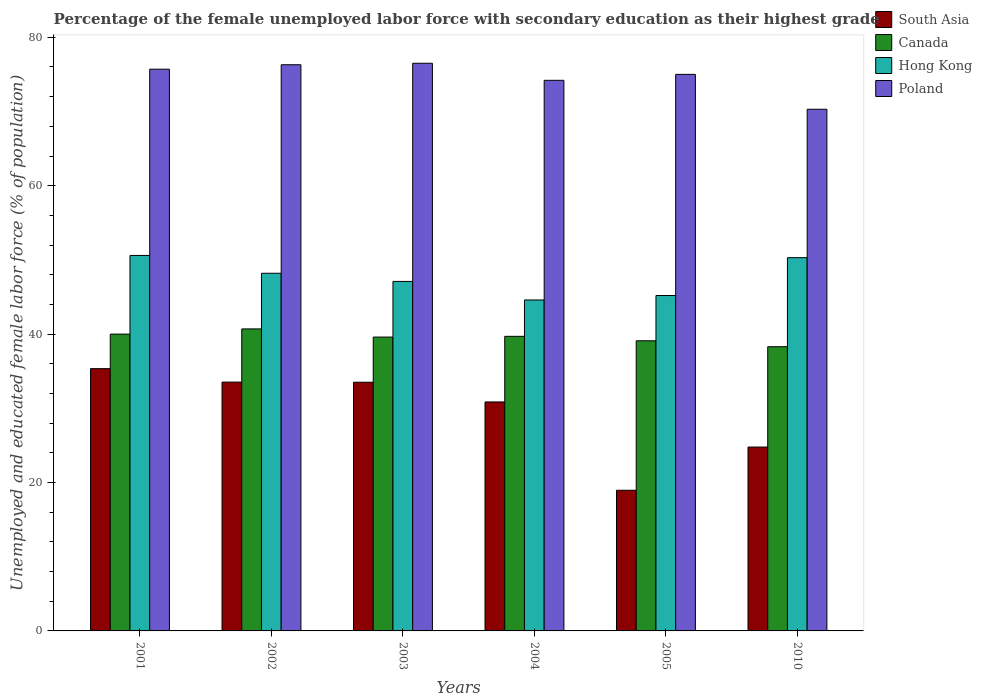How many different coloured bars are there?
Give a very brief answer. 4. Are the number of bars per tick equal to the number of legend labels?
Offer a very short reply. Yes. How many bars are there on the 4th tick from the left?
Offer a very short reply. 4. How many bars are there on the 5th tick from the right?
Ensure brevity in your answer.  4. What is the label of the 3rd group of bars from the left?
Give a very brief answer. 2003. In how many cases, is the number of bars for a given year not equal to the number of legend labels?
Ensure brevity in your answer.  0. What is the percentage of the unemployed female labor force with secondary education in South Asia in 2003?
Provide a short and direct response. 33.51. Across all years, what is the maximum percentage of the unemployed female labor force with secondary education in Canada?
Provide a succinct answer. 40.7. Across all years, what is the minimum percentage of the unemployed female labor force with secondary education in Canada?
Provide a short and direct response. 38.3. In which year was the percentage of the unemployed female labor force with secondary education in Poland maximum?
Your answer should be compact. 2003. In which year was the percentage of the unemployed female labor force with secondary education in Poland minimum?
Ensure brevity in your answer.  2010. What is the total percentage of the unemployed female labor force with secondary education in Canada in the graph?
Provide a succinct answer. 237.4. What is the difference between the percentage of the unemployed female labor force with secondary education in Hong Kong in 2001 and that in 2010?
Offer a very short reply. 0.3. What is the difference between the percentage of the unemployed female labor force with secondary education in Canada in 2001 and the percentage of the unemployed female labor force with secondary education in Hong Kong in 2004?
Keep it short and to the point. -4.6. What is the average percentage of the unemployed female labor force with secondary education in South Asia per year?
Keep it short and to the point. 29.5. In how many years, is the percentage of the unemployed female labor force with secondary education in Canada greater than 72 %?
Offer a very short reply. 0. What is the ratio of the percentage of the unemployed female labor force with secondary education in South Asia in 2004 to that in 2010?
Ensure brevity in your answer.  1.25. Is the percentage of the unemployed female labor force with secondary education in Canada in 2003 less than that in 2010?
Provide a short and direct response. No. Is the difference between the percentage of the unemployed female labor force with secondary education in Hong Kong in 2002 and 2005 greater than the difference between the percentage of the unemployed female labor force with secondary education in Canada in 2002 and 2005?
Keep it short and to the point. Yes. What is the difference between the highest and the second highest percentage of the unemployed female labor force with secondary education in Hong Kong?
Provide a succinct answer. 0.3. What is the difference between the highest and the lowest percentage of the unemployed female labor force with secondary education in Canada?
Offer a terse response. 2.4. Is the sum of the percentage of the unemployed female labor force with secondary education in Hong Kong in 2003 and 2010 greater than the maximum percentage of the unemployed female labor force with secondary education in Poland across all years?
Keep it short and to the point. Yes. What does the 3rd bar from the left in 2002 represents?
Make the answer very short. Hong Kong. Are all the bars in the graph horizontal?
Provide a short and direct response. No. How many years are there in the graph?
Offer a very short reply. 6. What is the difference between two consecutive major ticks on the Y-axis?
Your response must be concise. 20. Are the values on the major ticks of Y-axis written in scientific E-notation?
Your answer should be compact. No. Does the graph contain any zero values?
Ensure brevity in your answer.  No. Does the graph contain grids?
Keep it short and to the point. No. How are the legend labels stacked?
Ensure brevity in your answer.  Vertical. What is the title of the graph?
Provide a succinct answer. Percentage of the female unemployed labor force with secondary education as their highest grade. What is the label or title of the X-axis?
Give a very brief answer. Years. What is the label or title of the Y-axis?
Offer a very short reply. Unemployed and educated female labor force (% of population). What is the Unemployed and educated female labor force (% of population) of South Asia in 2001?
Give a very brief answer. 35.34. What is the Unemployed and educated female labor force (% of population) in Canada in 2001?
Ensure brevity in your answer.  40. What is the Unemployed and educated female labor force (% of population) of Hong Kong in 2001?
Your answer should be very brief. 50.6. What is the Unemployed and educated female labor force (% of population) of Poland in 2001?
Your answer should be very brief. 75.7. What is the Unemployed and educated female labor force (% of population) in South Asia in 2002?
Offer a very short reply. 33.53. What is the Unemployed and educated female labor force (% of population) of Canada in 2002?
Your response must be concise. 40.7. What is the Unemployed and educated female labor force (% of population) in Hong Kong in 2002?
Your answer should be compact. 48.2. What is the Unemployed and educated female labor force (% of population) of Poland in 2002?
Keep it short and to the point. 76.3. What is the Unemployed and educated female labor force (% of population) of South Asia in 2003?
Offer a very short reply. 33.51. What is the Unemployed and educated female labor force (% of population) in Canada in 2003?
Offer a very short reply. 39.6. What is the Unemployed and educated female labor force (% of population) in Hong Kong in 2003?
Offer a very short reply. 47.1. What is the Unemployed and educated female labor force (% of population) in Poland in 2003?
Give a very brief answer. 76.5. What is the Unemployed and educated female labor force (% of population) of South Asia in 2004?
Give a very brief answer. 30.86. What is the Unemployed and educated female labor force (% of population) of Canada in 2004?
Ensure brevity in your answer.  39.7. What is the Unemployed and educated female labor force (% of population) in Hong Kong in 2004?
Offer a very short reply. 44.6. What is the Unemployed and educated female labor force (% of population) in Poland in 2004?
Give a very brief answer. 74.2. What is the Unemployed and educated female labor force (% of population) of South Asia in 2005?
Provide a succinct answer. 18.96. What is the Unemployed and educated female labor force (% of population) in Canada in 2005?
Make the answer very short. 39.1. What is the Unemployed and educated female labor force (% of population) of Hong Kong in 2005?
Your answer should be very brief. 45.2. What is the Unemployed and educated female labor force (% of population) in South Asia in 2010?
Offer a very short reply. 24.78. What is the Unemployed and educated female labor force (% of population) of Canada in 2010?
Provide a succinct answer. 38.3. What is the Unemployed and educated female labor force (% of population) in Hong Kong in 2010?
Offer a terse response. 50.3. What is the Unemployed and educated female labor force (% of population) in Poland in 2010?
Offer a very short reply. 70.3. Across all years, what is the maximum Unemployed and educated female labor force (% of population) of South Asia?
Provide a succinct answer. 35.34. Across all years, what is the maximum Unemployed and educated female labor force (% of population) in Canada?
Your answer should be very brief. 40.7. Across all years, what is the maximum Unemployed and educated female labor force (% of population) of Hong Kong?
Make the answer very short. 50.6. Across all years, what is the maximum Unemployed and educated female labor force (% of population) in Poland?
Give a very brief answer. 76.5. Across all years, what is the minimum Unemployed and educated female labor force (% of population) of South Asia?
Give a very brief answer. 18.96. Across all years, what is the minimum Unemployed and educated female labor force (% of population) of Canada?
Provide a short and direct response. 38.3. Across all years, what is the minimum Unemployed and educated female labor force (% of population) of Hong Kong?
Make the answer very short. 44.6. Across all years, what is the minimum Unemployed and educated female labor force (% of population) of Poland?
Offer a terse response. 70.3. What is the total Unemployed and educated female labor force (% of population) of South Asia in the graph?
Offer a terse response. 176.98. What is the total Unemployed and educated female labor force (% of population) of Canada in the graph?
Offer a terse response. 237.4. What is the total Unemployed and educated female labor force (% of population) in Hong Kong in the graph?
Keep it short and to the point. 286. What is the total Unemployed and educated female labor force (% of population) of Poland in the graph?
Ensure brevity in your answer.  448. What is the difference between the Unemployed and educated female labor force (% of population) in South Asia in 2001 and that in 2002?
Your answer should be very brief. 1.81. What is the difference between the Unemployed and educated female labor force (% of population) in Canada in 2001 and that in 2002?
Offer a terse response. -0.7. What is the difference between the Unemployed and educated female labor force (% of population) of Poland in 2001 and that in 2002?
Keep it short and to the point. -0.6. What is the difference between the Unemployed and educated female labor force (% of population) of South Asia in 2001 and that in 2003?
Your answer should be very brief. 1.83. What is the difference between the Unemployed and educated female labor force (% of population) of Canada in 2001 and that in 2003?
Offer a terse response. 0.4. What is the difference between the Unemployed and educated female labor force (% of population) in Hong Kong in 2001 and that in 2003?
Make the answer very short. 3.5. What is the difference between the Unemployed and educated female labor force (% of population) in Poland in 2001 and that in 2003?
Keep it short and to the point. -0.8. What is the difference between the Unemployed and educated female labor force (% of population) of South Asia in 2001 and that in 2004?
Provide a succinct answer. 4.49. What is the difference between the Unemployed and educated female labor force (% of population) in Hong Kong in 2001 and that in 2004?
Your answer should be very brief. 6. What is the difference between the Unemployed and educated female labor force (% of population) of South Asia in 2001 and that in 2005?
Keep it short and to the point. 16.39. What is the difference between the Unemployed and educated female labor force (% of population) in Canada in 2001 and that in 2005?
Provide a succinct answer. 0.9. What is the difference between the Unemployed and educated female labor force (% of population) of South Asia in 2001 and that in 2010?
Make the answer very short. 10.57. What is the difference between the Unemployed and educated female labor force (% of population) of Canada in 2001 and that in 2010?
Offer a very short reply. 1.7. What is the difference between the Unemployed and educated female labor force (% of population) in Hong Kong in 2001 and that in 2010?
Keep it short and to the point. 0.3. What is the difference between the Unemployed and educated female labor force (% of population) of Poland in 2001 and that in 2010?
Make the answer very short. 5.4. What is the difference between the Unemployed and educated female labor force (% of population) of South Asia in 2002 and that in 2003?
Ensure brevity in your answer.  0.02. What is the difference between the Unemployed and educated female labor force (% of population) of Canada in 2002 and that in 2003?
Give a very brief answer. 1.1. What is the difference between the Unemployed and educated female labor force (% of population) in South Asia in 2002 and that in 2004?
Offer a very short reply. 2.67. What is the difference between the Unemployed and educated female labor force (% of population) in Hong Kong in 2002 and that in 2004?
Make the answer very short. 3.6. What is the difference between the Unemployed and educated female labor force (% of population) in Poland in 2002 and that in 2004?
Provide a short and direct response. 2.1. What is the difference between the Unemployed and educated female labor force (% of population) of South Asia in 2002 and that in 2005?
Keep it short and to the point. 14.58. What is the difference between the Unemployed and educated female labor force (% of population) in Canada in 2002 and that in 2005?
Your answer should be very brief. 1.6. What is the difference between the Unemployed and educated female labor force (% of population) in South Asia in 2002 and that in 2010?
Your response must be concise. 8.75. What is the difference between the Unemployed and educated female labor force (% of population) in Canada in 2002 and that in 2010?
Keep it short and to the point. 2.4. What is the difference between the Unemployed and educated female labor force (% of population) in Hong Kong in 2002 and that in 2010?
Offer a very short reply. -2.1. What is the difference between the Unemployed and educated female labor force (% of population) of Poland in 2002 and that in 2010?
Give a very brief answer. 6. What is the difference between the Unemployed and educated female labor force (% of population) in South Asia in 2003 and that in 2004?
Your response must be concise. 2.66. What is the difference between the Unemployed and educated female labor force (% of population) in South Asia in 2003 and that in 2005?
Offer a terse response. 14.56. What is the difference between the Unemployed and educated female labor force (% of population) in Canada in 2003 and that in 2005?
Ensure brevity in your answer.  0.5. What is the difference between the Unemployed and educated female labor force (% of population) of Poland in 2003 and that in 2005?
Offer a terse response. 1.5. What is the difference between the Unemployed and educated female labor force (% of population) of South Asia in 2003 and that in 2010?
Provide a short and direct response. 8.74. What is the difference between the Unemployed and educated female labor force (% of population) of Poland in 2003 and that in 2010?
Offer a terse response. 6.2. What is the difference between the Unemployed and educated female labor force (% of population) in South Asia in 2004 and that in 2005?
Give a very brief answer. 11.9. What is the difference between the Unemployed and educated female labor force (% of population) in Canada in 2004 and that in 2005?
Your response must be concise. 0.6. What is the difference between the Unemployed and educated female labor force (% of population) of Poland in 2004 and that in 2005?
Your answer should be very brief. -0.8. What is the difference between the Unemployed and educated female labor force (% of population) in South Asia in 2004 and that in 2010?
Provide a succinct answer. 6.08. What is the difference between the Unemployed and educated female labor force (% of population) of Canada in 2004 and that in 2010?
Your answer should be compact. 1.4. What is the difference between the Unemployed and educated female labor force (% of population) in South Asia in 2005 and that in 2010?
Provide a short and direct response. -5.82. What is the difference between the Unemployed and educated female labor force (% of population) in Poland in 2005 and that in 2010?
Your answer should be compact. 4.7. What is the difference between the Unemployed and educated female labor force (% of population) in South Asia in 2001 and the Unemployed and educated female labor force (% of population) in Canada in 2002?
Offer a very short reply. -5.36. What is the difference between the Unemployed and educated female labor force (% of population) in South Asia in 2001 and the Unemployed and educated female labor force (% of population) in Hong Kong in 2002?
Ensure brevity in your answer.  -12.86. What is the difference between the Unemployed and educated female labor force (% of population) of South Asia in 2001 and the Unemployed and educated female labor force (% of population) of Poland in 2002?
Your response must be concise. -40.96. What is the difference between the Unemployed and educated female labor force (% of population) in Canada in 2001 and the Unemployed and educated female labor force (% of population) in Poland in 2002?
Make the answer very short. -36.3. What is the difference between the Unemployed and educated female labor force (% of population) of Hong Kong in 2001 and the Unemployed and educated female labor force (% of population) of Poland in 2002?
Your response must be concise. -25.7. What is the difference between the Unemployed and educated female labor force (% of population) of South Asia in 2001 and the Unemployed and educated female labor force (% of population) of Canada in 2003?
Your response must be concise. -4.26. What is the difference between the Unemployed and educated female labor force (% of population) in South Asia in 2001 and the Unemployed and educated female labor force (% of population) in Hong Kong in 2003?
Provide a short and direct response. -11.76. What is the difference between the Unemployed and educated female labor force (% of population) of South Asia in 2001 and the Unemployed and educated female labor force (% of population) of Poland in 2003?
Provide a succinct answer. -41.16. What is the difference between the Unemployed and educated female labor force (% of population) of Canada in 2001 and the Unemployed and educated female labor force (% of population) of Poland in 2003?
Your response must be concise. -36.5. What is the difference between the Unemployed and educated female labor force (% of population) of Hong Kong in 2001 and the Unemployed and educated female labor force (% of population) of Poland in 2003?
Ensure brevity in your answer.  -25.9. What is the difference between the Unemployed and educated female labor force (% of population) of South Asia in 2001 and the Unemployed and educated female labor force (% of population) of Canada in 2004?
Offer a terse response. -4.36. What is the difference between the Unemployed and educated female labor force (% of population) of South Asia in 2001 and the Unemployed and educated female labor force (% of population) of Hong Kong in 2004?
Provide a short and direct response. -9.26. What is the difference between the Unemployed and educated female labor force (% of population) of South Asia in 2001 and the Unemployed and educated female labor force (% of population) of Poland in 2004?
Provide a succinct answer. -38.86. What is the difference between the Unemployed and educated female labor force (% of population) of Canada in 2001 and the Unemployed and educated female labor force (% of population) of Hong Kong in 2004?
Provide a short and direct response. -4.6. What is the difference between the Unemployed and educated female labor force (% of population) of Canada in 2001 and the Unemployed and educated female labor force (% of population) of Poland in 2004?
Your answer should be compact. -34.2. What is the difference between the Unemployed and educated female labor force (% of population) in Hong Kong in 2001 and the Unemployed and educated female labor force (% of population) in Poland in 2004?
Offer a very short reply. -23.6. What is the difference between the Unemployed and educated female labor force (% of population) of South Asia in 2001 and the Unemployed and educated female labor force (% of population) of Canada in 2005?
Offer a terse response. -3.76. What is the difference between the Unemployed and educated female labor force (% of population) of South Asia in 2001 and the Unemployed and educated female labor force (% of population) of Hong Kong in 2005?
Offer a terse response. -9.86. What is the difference between the Unemployed and educated female labor force (% of population) in South Asia in 2001 and the Unemployed and educated female labor force (% of population) in Poland in 2005?
Your response must be concise. -39.66. What is the difference between the Unemployed and educated female labor force (% of population) of Canada in 2001 and the Unemployed and educated female labor force (% of population) of Poland in 2005?
Keep it short and to the point. -35. What is the difference between the Unemployed and educated female labor force (% of population) in Hong Kong in 2001 and the Unemployed and educated female labor force (% of population) in Poland in 2005?
Provide a succinct answer. -24.4. What is the difference between the Unemployed and educated female labor force (% of population) of South Asia in 2001 and the Unemployed and educated female labor force (% of population) of Canada in 2010?
Ensure brevity in your answer.  -2.96. What is the difference between the Unemployed and educated female labor force (% of population) of South Asia in 2001 and the Unemployed and educated female labor force (% of population) of Hong Kong in 2010?
Offer a very short reply. -14.96. What is the difference between the Unemployed and educated female labor force (% of population) in South Asia in 2001 and the Unemployed and educated female labor force (% of population) in Poland in 2010?
Your answer should be very brief. -34.96. What is the difference between the Unemployed and educated female labor force (% of population) in Canada in 2001 and the Unemployed and educated female labor force (% of population) in Poland in 2010?
Your answer should be compact. -30.3. What is the difference between the Unemployed and educated female labor force (% of population) in Hong Kong in 2001 and the Unemployed and educated female labor force (% of population) in Poland in 2010?
Your answer should be compact. -19.7. What is the difference between the Unemployed and educated female labor force (% of population) of South Asia in 2002 and the Unemployed and educated female labor force (% of population) of Canada in 2003?
Provide a short and direct response. -6.07. What is the difference between the Unemployed and educated female labor force (% of population) of South Asia in 2002 and the Unemployed and educated female labor force (% of population) of Hong Kong in 2003?
Your answer should be compact. -13.57. What is the difference between the Unemployed and educated female labor force (% of population) in South Asia in 2002 and the Unemployed and educated female labor force (% of population) in Poland in 2003?
Offer a terse response. -42.97. What is the difference between the Unemployed and educated female labor force (% of population) of Canada in 2002 and the Unemployed and educated female labor force (% of population) of Poland in 2003?
Your response must be concise. -35.8. What is the difference between the Unemployed and educated female labor force (% of population) of Hong Kong in 2002 and the Unemployed and educated female labor force (% of population) of Poland in 2003?
Keep it short and to the point. -28.3. What is the difference between the Unemployed and educated female labor force (% of population) in South Asia in 2002 and the Unemployed and educated female labor force (% of population) in Canada in 2004?
Make the answer very short. -6.17. What is the difference between the Unemployed and educated female labor force (% of population) in South Asia in 2002 and the Unemployed and educated female labor force (% of population) in Hong Kong in 2004?
Your response must be concise. -11.07. What is the difference between the Unemployed and educated female labor force (% of population) in South Asia in 2002 and the Unemployed and educated female labor force (% of population) in Poland in 2004?
Your answer should be very brief. -40.67. What is the difference between the Unemployed and educated female labor force (% of population) in Canada in 2002 and the Unemployed and educated female labor force (% of population) in Hong Kong in 2004?
Ensure brevity in your answer.  -3.9. What is the difference between the Unemployed and educated female labor force (% of population) of Canada in 2002 and the Unemployed and educated female labor force (% of population) of Poland in 2004?
Ensure brevity in your answer.  -33.5. What is the difference between the Unemployed and educated female labor force (% of population) of Hong Kong in 2002 and the Unemployed and educated female labor force (% of population) of Poland in 2004?
Your response must be concise. -26. What is the difference between the Unemployed and educated female labor force (% of population) of South Asia in 2002 and the Unemployed and educated female labor force (% of population) of Canada in 2005?
Your answer should be very brief. -5.57. What is the difference between the Unemployed and educated female labor force (% of population) in South Asia in 2002 and the Unemployed and educated female labor force (% of population) in Hong Kong in 2005?
Offer a terse response. -11.67. What is the difference between the Unemployed and educated female labor force (% of population) of South Asia in 2002 and the Unemployed and educated female labor force (% of population) of Poland in 2005?
Provide a short and direct response. -41.47. What is the difference between the Unemployed and educated female labor force (% of population) of Canada in 2002 and the Unemployed and educated female labor force (% of population) of Poland in 2005?
Keep it short and to the point. -34.3. What is the difference between the Unemployed and educated female labor force (% of population) in Hong Kong in 2002 and the Unemployed and educated female labor force (% of population) in Poland in 2005?
Your response must be concise. -26.8. What is the difference between the Unemployed and educated female labor force (% of population) of South Asia in 2002 and the Unemployed and educated female labor force (% of population) of Canada in 2010?
Provide a succinct answer. -4.77. What is the difference between the Unemployed and educated female labor force (% of population) of South Asia in 2002 and the Unemployed and educated female labor force (% of population) of Hong Kong in 2010?
Your answer should be compact. -16.77. What is the difference between the Unemployed and educated female labor force (% of population) of South Asia in 2002 and the Unemployed and educated female labor force (% of population) of Poland in 2010?
Offer a terse response. -36.77. What is the difference between the Unemployed and educated female labor force (% of population) in Canada in 2002 and the Unemployed and educated female labor force (% of population) in Hong Kong in 2010?
Offer a terse response. -9.6. What is the difference between the Unemployed and educated female labor force (% of population) of Canada in 2002 and the Unemployed and educated female labor force (% of population) of Poland in 2010?
Offer a very short reply. -29.6. What is the difference between the Unemployed and educated female labor force (% of population) in Hong Kong in 2002 and the Unemployed and educated female labor force (% of population) in Poland in 2010?
Offer a terse response. -22.1. What is the difference between the Unemployed and educated female labor force (% of population) in South Asia in 2003 and the Unemployed and educated female labor force (% of population) in Canada in 2004?
Provide a succinct answer. -6.19. What is the difference between the Unemployed and educated female labor force (% of population) in South Asia in 2003 and the Unemployed and educated female labor force (% of population) in Hong Kong in 2004?
Your answer should be very brief. -11.09. What is the difference between the Unemployed and educated female labor force (% of population) in South Asia in 2003 and the Unemployed and educated female labor force (% of population) in Poland in 2004?
Your answer should be compact. -40.69. What is the difference between the Unemployed and educated female labor force (% of population) of Canada in 2003 and the Unemployed and educated female labor force (% of population) of Hong Kong in 2004?
Provide a short and direct response. -5. What is the difference between the Unemployed and educated female labor force (% of population) in Canada in 2003 and the Unemployed and educated female labor force (% of population) in Poland in 2004?
Your response must be concise. -34.6. What is the difference between the Unemployed and educated female labor force (% of population) in Hong Kong in 2003 and the Unemployed and educated female labor force (% of population) in Poland in 2004?
Ensure brevity in your answer.  -27.1. What is the difference between the Unemployed and educated female labor force (% of population) of South Asia in 2003 and the Unemployed and educated female labor force (% of population) of Canada in 2005?
Your answer should be compact. -5.59. What is the difference between the Unemployed and educated female labor force (% of population) in South Asia in 2003 and the Unemployed and educated female labor force (% of population) in Hong Kong in 2005?
Your answer should be compact. -11.69. What is the difference between the Unemployed and educated female labor force (% of population) in South Asia in 2003 and the Unemployed and educated female labor force (% of population) in Poland in 2005?
Your answer should be compact. -41.49. What is the difference between the Unemployed and educated female labor force (% of population) of Canada in 2003 and the Unemployed and educated female labor force (% of population) of Poland in 2005?
Ensure brevity in your answer.  -35.4. What is the difference between the Unemployed and educated female labor force (% of population) of Hong Kong in 2003 and the Unemployed and educated female labor force (% of population) of Poland in 2005?
Give a very brief answer. -27.9. What is the difference between the Unemployed and educated female labor force (% of population) of South Asia in 2003 and the Unemployed and educated female labor force (% of population) of Canada in 2010?
Your response must be concise. -4.79. What is the difference between the Unemployed and educated female labor force (% of population) in South Asia in 2003 and the Unemployed and educated female labor force (% of population) in Hong Kong in 2010?
Your answer should be very brief. -16.79. What is the difference between the Unemployed and educated female labor force (% of population) of South Asia in 2003 and the Unemployed and educated female labor force (% of population) of Poland in 2010?
Your response must be concise. -36.79. What is the difference between the Unemployed and educated female labor force (% of population) of Canada in 2003 and the Unemployed and educated female labor force (% of population) of Poland in 2010?
Offer a terse response. -30.7. What is the difference between the Unemployed and educated female labor force (% of population) in Hong Kong in 2003 and the Unemployed and educated female labor force (% of population) in Poland in 2010?
Make the answer very short. -23.2. What is the difference between the Unemployed and educated female labor force (% of population) in South Asia in 2004 and the Unemployed and educated female labor force (% of population) in Canada in 2005?
Ensure brevity in your answer.  -8.24. What is the difference between the Unemployed and educated female labor force (% of population) in South Asia in 2004 and the Unemployed and educated female labor force (% of population) in Hong Kong in 2005?
Your answer should be compact. -14.34. What is the difference between the Unemployed and educated female labor force (% of population) of South Asia in 2004 and the Unemployed and educated female labor force (% of population) of Poland in 2005?
Provide a short and direct response. -44.14. What is the difference between the Unemployed and educated female labor force (% of population) of Canada in 2004 and the Unemployed and educated female labor force (% of population) of Hong Kong in 2005?
Ensure brevity in your answer.  -5.5. What is the difference between the Unemployed and educated female labor force (% of population) in Canada in 2004 and the Unemployed and educated female labor force (% of population) in Poland in 2005?
Provide a short and direct response. -35.3. What is the difference between the Unemployed and educated female labor force (% of population) in Hong Kong in 2004 and the Unemployed and educated female labor force (% of population) in Poland in 2005?
Make the answer very short. -30.4. What is the difference between the Unemployed and educated female labor force (% of population) of South Asia in 2004 and the Unemployed and educated female labor force (% of population) of Canada in 2010?
Offer a very short reply. -7.44. What is the difference between the Unemployed and educated female labor force (% of population) in South Asia in 2004 and the Unemployed and educated female labor force (% of population) in Hong Kong in 2010?
Provide a short and direct response. -19.44. What is the difference between the Unemployed and educated female labor force (% of population) in South Asia in 2004 and the Unemployed and educated female labor force (% of population) in Poland in 2010?
Your answer should be very brief. -39.44. What is the difference between the Unemployed and educated female labor force (% of population) in Canada in 2004 and the Unemployed and educated female labor force (% of population) in Hong Kong in 2010?
Give a very brief answer. -10.6. What is the difference between the Unemployed and educated female labor force (% of population) of Canada in 2004 and the Unemployed and educated female labor force (% of population) of Poland in 2010?
Ensure brevity in your answer.  -30.6. What is the difference between the Unemployed and educated female labor force (% of population) of Hong Kong in 2004 and the Unemployed and educated female labor force (% of population) of Poland in 2010?
Provide a succinct answer. -25.7. What is the difference between the Unemployed and educated female labor force (% of population) of South Asia in 2005 and the Unemployed and educated female labor force (% of population) of Canada in 2010?
Your response must be concise. -19.34. What is the difference between the Unemployed and educated female labor force (% of population) of South Asia in 2005 and the Unemployed and educated female labor force (% of population) of Hong Kong in 2010?
Your response must be concise. -31.34. What is the difference between the Unemployed and educated female labor force (% of population) of South Asia in 2005 and the Unemployed and educated female labor force (% of population) of Poland in 2010?
Provide a short and direct response. -51.34. What is the difference between the Unemployed and educated female labor force (% of population) of Canada in 2005 and the Unemployed and educated female labor force (% of population) of Poland in 2010?
Provide a succinct answer. -31.2. What is the difference between the Unemployed and educated female labor force (% of population) of Hong Kong in 2005 and the Unemployed and educated female labor force (% of population) of Poland in 2010?
Provide a succinct answer. -25.1. What is the average Unemployed and educated female labor force (% of population) in South Asia per year?
Your answer should be compact. 29.5. What is the average Unemployed and educated female labor force (% of population) in Canada per year?
Make the answer very short. 39.57. What is the average Unemployed and educated female labor force (% of population) in Hong Kong per year?
Ensure brevity in your answer.  47.67. What is the average Unemployed and educated female labor force (% of population) of Poland per year?
Give a very brief answer. 74.67. In the year 2001, what is the difference between the Unemployed and educated female labor force (% of population) of South Asia and Unemployed and educated female labor force (% of population) of Canada?
Provide a succinct answer. -4.66. In the year 2001, what is the difference between the Unemployed and educated female labor force (% of population) of South Asia and Unemployed and educated female labor force (% of population) of Hong Kong?
Give a very brief answer. -15.26. In the year 2001, what is the difference between the Unemployed and educated female labor force (% of population) in South Asia and Unemployed and educated female labor force (% of population) in Poland?
Offer a terse response. -40.36. In the year 2001, what is the difference between the Unemployed and educated female labor force (% of population) in Canada and Unemployed and educated female labor force (% of population) in Poland?
Provide a succinct answer. -35.7. In the year 2001, what is the difference between the Unemployed and educated female labor force (% of population) in Hong Kong and Unemployed and educated female labor force (% of population) in Poland?
Make the answer very short. -25.1. In the year 2002, what is the difference between the Unemployed and educated female labor force (% of population) of South Asia and Unemployed and educated female labor force (% of population) of Canada?
Provide a succinct answer. -7.17. In the year 2002, what is the difference between the Unemployed and educated female labor force (% of population) of South Asia and Unemployed and educated female labor force (% of population) of Hong Kong?
Offer a very short reply. -14.67. In the year 2002, what is the difference between the Unemployed and educated female labor force (% of population) of South Asia and Unemployed and educated female labor force (% of population) of Poland?
Your response must be concise. -42.77. In the year 2002, what is the difference between the Unemployed and educated female labor force (% of population) of Canada and Unemployed and educated female labor force (% of population) of Hong Kong?
Make the answer very short. -7.5. In the year 2002, what is the difference between the Unemployed and educated female labor force (% of population) of Canada and Unemployed and educated female labor force (% of population) of Poland?
Ensure brevity in your answer.  -35.6. In the year 2002, what is the difference between the Unemployed and educated female labor force (% of population) in Hong Kong and Unemployed and educated female labor force (% of population) in Poland?
Make the answer very short. -28.1. In the year 2003, what is the difference between the Unemployed and educated female labor force (% of population) in South Asia and Unemployed and educated female labor force (% of population) in Canada?
Offer a very short reply. -6.09. In the year 2003, what is the difference between the Unemployed and educated female labor force (% of population) of South Asia and Unemployed and educated female labor force (% of population) of Hong Kong?
Give a very brief answer. -13.59. In the year 2003, what is the difference between the Unemployed and educated female labor force (% of population) in South Asia and Unemployed and educated female labor force (% of population) in Poland?
Make the answer very short. -42.99. In the year 2003, what is the difference between the Unemployed and educated female labor force (% of population) of Canada and Unemployed and educated female labor force (% of population) of Poland?
Make the answer very short. -36.9. In the year 2003, what is the difference between the Unemployed and educated female labor force (% of population) in Hong Kong and Unemployed and educated female labor force (% of population) in Poland?
Ensure brevity in your answer.  -29.4. In the year 2004, what is the difference between the Unemployed and educated female labor force (% of population) in South Asia and Unemployed and educated female labor force (% of population) in Canada?
Ensure brevity in your answer.  -8.84. In the year 2004, what is the difference between the Unemployed and educated female labor force (% of population) of South Asia and Unemployed and educated female labor force (% of population) of Hong Kong?
Give a very brief answer. -13.74. In the year 2004, what is the difference between the Unemployed and educated female labor force (% of population) of South Asia and Unemployed and educated female labor force (% of population) of Poland?
Give a very brief answer. -43.34. In the year 2004, what is the difference between the Unemployed and educated female labor force (% of population) in Canada and Unemployed and educated female labor force (% of population) in Hong Kong?
Offer a very short reply. -4.9. In the year 2004, what is the difference between the Unemployed and educated female labor force (% of population) in Canada and Unemployed and educated female labor force (% of population) in Poland?
Ensure brevity in your answer.  -34.5. In the year 2004, what is the difference between the Unemployed and educated female labor force (% of population) of Hong Kong and Unemployed and educated female labor force (% of population) of Poland?
Your answer should be compact. -29.6. In the year 2005, what is the difference between the Unemployed and educated female labor force (% of population) in South Asia and Unemployed and educated female labor force (% of population) in Canada?
Your answer should be compact. -20.14. In the year 2005, what is the difference between the Unemployed and educated female labor force (% of population) of South Asia and Unemployed and educated female labor force (% of population) of Hong Kong?
Your response must be concise. -26.24. In the year 2005, what is the difference between the Unemployed and educated female labor force (% of population) of South Asia and Unemployed and educated female labor force (% of population) of Poland?
Make the answer very short. -56.04. In the year 2005, what is the difference between the Unemployed and educated female labor force (% of population) of Canada and Unemployed and educated female labor force (% of population) of Poland?
Give a very brief answer. -35.9. In the year 2005, what is the difference between the Unemployed and educated female labor force (% of population) in Hong Kong and Unemployed and educated female labor force (% of population) in Poland?
Your answer should be very brief. -29.8. In the year 2010, what is the difference between the Unemployed and educated female labor force (% of population) of South Asia and Unemployed and educated female labor force (% of population) of Canada?
Your response must be concise. -13.52. In the year 2010, what is the difference between the Unemployed and educated female labor force (% of population) in South Asia and Unemployed and educated female labor force (% of population) in Hong Kong?
Offer a terse response. -25.52. In the year 2010, what is the difference between the Unemployed and educated female labor force (% of population) in South Asia and Unemployed and educated female labor force (% of population) in Poland?
Your answer should be very brief. -45.52. In the year 2010, what is the difference between the Unemployed and educated female labor force (% of population) of Canada and Unemployed and educated female labor force (% of population) of Hong Kong?
Make the answer very short. -12. In the year 2010, what is the difference between the Unemployed and educated female labor force (% of population) of Canada and Unemployed and educated female labor force (% of population) of Poland?
Provide a succinct answer. -32. What is the ratio of the Unemployed and educated female labor force (% of population) in South Asia in 2001 to that in 2002?
Offer a very short reply. 1.05. What is the ratio of the Unemployed and educated female labor force (% of population) in Canada in 2001 to that in 2002?
Offer a terse response. 0.98. What is the ratio of the Unemployed and educated female labor force (% of population) in Hong Kong in 2001 to that in 2002?
Provide a succinct answer. 1.05. What is the ratio of the Unemployed and educated female labor force (% of population) of South Asia in 2001 to that in 2003?
Provide a short and direct response. 1.05. What is the ratio of the Unemployed and educated female labor force (% of population) of Hong Kong in 2001 to that in 2003?
Keep it short and to the point. 1.07. What is the ratio of the Unemployed and educated female labor force (% of population) of South Asia in 2001 to that in 2004?
Keep it short and to the point. 1.15. What is the ratio of the Unemployed and educated female labor force (% of population) of Canada in 2001 to that in 2004?
Your answer should be very brief. 1.01. What is the ratio of the Unemployed and educated female labor force (% of population) of Hong Kong in 2001 to that in 2004?
Provide a succinct answer. 1.13. What is the ratio of the Unemployed and educated female labor force (% of population) in Poland in 2001 to that in 2004?
Give a very brief answer. 1.02. What is the ratio of the Unemployed and educated female labor force (% of population) in South Asia in 2001 to that in 2005?
Your response must be concise. 1.86. What is the ratio of the Unemployed and educated female labor force (% of population) of Canada in 2001 to that in 2005?
Your answer should be very brief. 1.02. What is the ratio of the Unemployed and educated female labor force (% of population) in Hong Kong in 2001 to that in 2005?
Keep it short and to the point. 1.12. What is the ratio of the Unemployed and educated female labor force (% of population) in Poland in 2001 to that in 2005?
Your response must be concise. 1.01. What is the ratio of the Unemployed and educated female labor force (% of population) in South Asia in 2001 to that in 2010?
Give a very brief answer. 1.43. What is the ratio of the Unemployed and educated female labor force (% of population) in Canada in 2001 to that in 2010?
Keep it short and to the point. 1.04. What is the ratio of the Unemployed and educated female labor force (% of population) of Hong Kong in 2001 to that in 2010?
Offer a very short reply. 1.01. What is the ratio of the Unemployed and educated female labor force (% of population) of Poland in 2001 to that in 2010?
Offer a very short reply. 1.08. What is the ratio of the Unemployed and educated female labor force (% of population) in Canada in 2002 to that in 2003?
Provide a short and direct response. 1.03. What is the ratio of the Unemployed and educated female labor force (% of population) in Hong Kong in 2002 to that in 2003?
Your answer should be compact. 1.02. What is the ratio of the Unemployed and educated female labor force (% of population) of South Asia in 2002 to that in 2004?
Provide a succinct answer. 1.09. What is the ratio of the Unemployed and educated female labor force (% of population) of Canada in 2002 to that in 2004?
Offer a very short reply. 1.03. What is the ratio of the Unemployed and educated female labor force (% of population) in Hong Kong in 2002 to that in 2004?
Offer a very short reply. 1.08. What is the ratio of the Unemployed and educated female labor force (% of population) in Poland in 2002 to that in 2004?
Make the answer very short. 1.03. What is the ratio of the Unemployed and educated female labor force (% of population) in South Asia in 2002 to that in 2005?
Your answer should be compact. 1.77. What is the ratio of the Unemployed and educated female labor force (% of population) of Canada in 2002 to that in 2005?
Your response must be concise. 1.04. What is the ratio of the Unemployed and educated female labor force (% of population) in Hong Kong in 2002 to that in 2005?
Offer a very short reply. 1.07. What is the ratio of the Unemployed and educated female labor force (% of population) of Poland in 2002 to that in 2005?
Offer a very short reply. 1.02. What is the ratio of the Unemployed and educated female labor force (% of population) of South Asia in 2002 to that in 2010?
Your answer should be very brief. 1.35. What is the ratio of the Unemployed and educated female labor force (% of population) of Canada in 2002 to that in 2010?
Provide a short and direct response. 1.06. What is the ratio of the Unemployed and educated female labor force (% of population) of Poland in 2002 to that in 2010?
Ensure brevity in your answer.  1.09. What is the ratio of the Unemployed and educated female labor force (% of population) of South Asia in 2003 to that in 2004?
Keep it short and to the point. 1.09. What is the ratio of the Unemployed and educated female labor force (% of population) of Canada in 2003 to that in 2004?
Ensure brevity in your answer.  1. What is the ratio of the Unemployed and educated female labor force (% of population) in Hong Kong in 2003 to that in 2004?
Give a very brief answer. 1.06. What is the ratio of the Unemployed and educated female labor force (% of population) in Poland in 2003 to that in 2004?
Make the answer very short. 1.03. What is the ratio of the Unemployed and educated female labor force (% of population) of South Asia in 2003 to that in 2005?
Your answer should be compact. 1.77. What is the ratio of the Unemployed and educated female labor force (% of population) in Canada in 2003 to that in 2005?
Your answer should be very brief. 1.01. What is the ratio of the Unemployed and educated female labor force (% of population) of Hong Kong in 2003 to that in 2005?
Ensure brevity in your answer.  1.04. What is the ratio of the Unemployed and educated female labor force (% of population) of Poland in 2003 to that in 2005?
Provide a succinct answer. 1.02. What is the ratio of the Unemployed and educated female labor force (% of population) in South Asia in 2003 to that in 2010?
Ensure brevity in your answer.  1.35. What is the ratio of the Unemployed and educated female labor force (% of population) of Canada in 2003 to that in 2010?
Your response must be concise. 1.03. What is the ratio of the Unemployed and educated female labor force (% of population) in Hong Kong in 2003 to that in 2010?
Offer a very short reply. 0.94. What is the ratio of the Unemployed and educated female labor force (% of population) in Poland in 2003 to that in 2010?
Offer a terse response. 1.09. What is the ratio of the Unemployed and educated female labor force (% of population) in South Asia in 2004 to that in 2005?
Make the answer very short. 1.63. What is the ratio of the Unemployed and educated female labor force (% of population) in Canada in 2004 to that in 2005?
Provide a short and direct response. 1.02. What is the ratio of the Unemployed and educated female labor force (% of population) in Hong Kong in 2004 to that in 2005?
Your response must be concise. 0.99. What is the ratio of the Unemployed and educated female labor force (% of population) of Poland in 2004 to that in 2005?
Your response must be concise. 0.99. What is the ratio of the Unemployed and educated female labor force (% of population) in South Asia in 2004 to that in 2010?
Make the answer very short. 1.25. What is the ratio of the Unemployed and educated female labor force (% of population) in Canada in 2004 to that in 2010?
Make the answer very short. 1.04. What is the ratio of the Unemployed and educated female labor force (% of population) in Hong Kong in 2004 to that in 2010?
Your answer should be compact. 0.89. What is the ratio of the Unemployed and educated female labor force (% of population) in Poland in 2004 to that in 2010?
Ensure brevity in your answer.  1.06. What is the ratio of the Unemployed and educated female labor force (% of population) of South Asia in 2005 to that in 2010?
Offer a terse response. 0.77. What is the ratio of the Unemployed and educated female labor force (% of population) in Canada in 2005 to that in 2010?
Provide a succinct answer. 1.02. What is the ratio of the Unemployed and educated female labor force (% of population) of Hong Kong in 2005 to that in 2010?
Make the answer very short. 0.9. What is the ratio of the Unemployed and educated female labor force (% of population) of Poland in 2005 to that in 2010?
Your answer should be compact. 1.07. What is the difference between the highest and the second highest Unemployed and educated female labor force (% of population) of South Asia?
Your response must be concise. 1.81. What is the difference between the highest and the second highest Unemployed and educated female labor force (% of population) in Canada?
Make the answer very short. 0.7. What is the difference between the highest and the second highest Unemployed and educated female labor force (% of population) of Hong Kong?
Provide a short and direct response. 0.3. What is the difference between the highest and the lowest Unemployed and educated female labor force (% of population) of South Asia?
Offer a terse response. 16.39. What is the difference between the highest and the lowest Unemployed and educated female labor force (% of population) in Canada?
Keep it short and to the point. 2.4. What is the difference between the highest and the lowest Unemployed and educated female labor force (% of population) in Poland?
Ensure brevity in your answer.  6.2. 